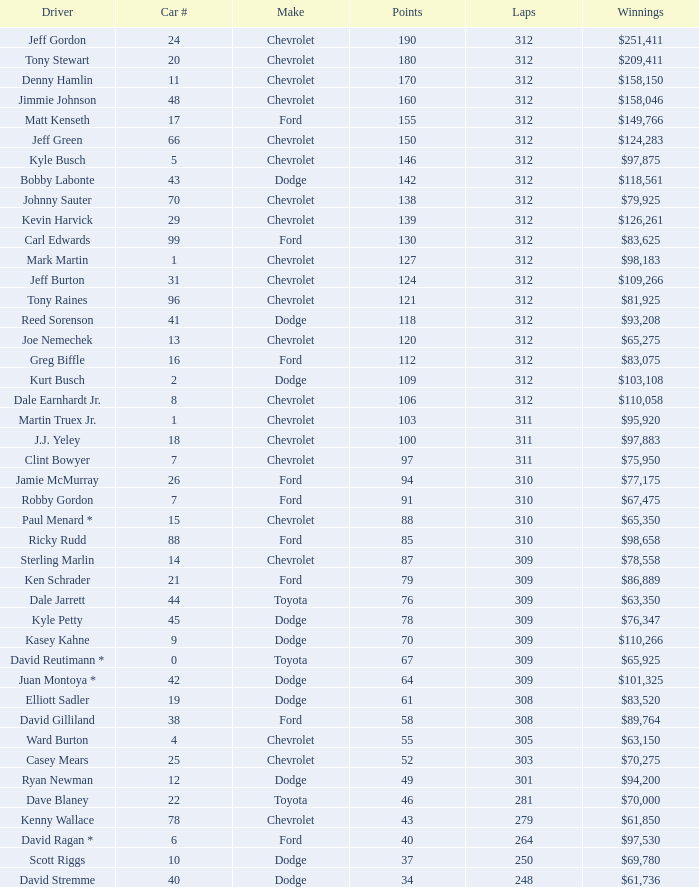What is the total number of laps for a car with a number greater than 1, belonging to ford, and having 155 points? 312.0. Help me parse the entirety of this table. {'header': ['Driver', 'Car #', 'Make', 'Points', 'Laps', 'Winnings'], 'rows': [['Jeff Gordon', '24', 'Chevrolet', '190', '312', '$251,411'], ['Tony Stewart', '20', 'Chevrolet', '180', '312', '$209,411'], ['Denny Hamlin', '11', 'Chevrolet', '170', '312', '$158,150'], ['Jimmie Johnson', '48', 'Chevrolet', '160', '312', '$158,046'], ['Matt Kenseth', '17', 'Ford', '155', '312', '$149,766'], ['Jeff Green', '66', 'Chevrolet', '150', '312', '$124,283'], ['Kyle Busch', '5', 'Chevrolet', '146', '312', '$97,875'], ['Bobby Labonte', '43', 'Dodge', '142', '312', '$118,561'], ['Johnny Sauter', '70', 'Chevrolet', '138', '312', '$79,925'], ['Kevin Harvick', '29', 'Chevrolet', '139', '312', '$126,261'], ['Carl Edwards', '99', 'Ford', '130', '312', '$83,625'], ['Mark Martin', '1', 'Chevrolet', '127', '312', '$98,183'], ['Jeff Burton', '31', 'Chevrolet', '124', '312', '$109,266'], ['Tony Raines', '96', 'Chevrolet', '121', '312', '$81,925'], ['Reed Sorenson', '41', 'Dodge', '118', '312', '$93,208'], ['Joe Nemechek', '13', 'Chevrolet', '120', '312', '$65,275'], ['Greg Biffle', '16', 'Ford', '112', '312', '$83,075'], ['Kurt Busch', '2', 'Dodge', '109', '312', '$103,108'], ['Dale Earnhardt Jr.', '8', 'Chevrolet', '106', '312', '$110,058'], ['Martin Truex Jr.', '1', 'Chevrolet', '103', '311', '$95,920'], ['J.J. Yeley', '18', 'Chevrolet', '100', '311', '$97,883'], ['Clint Bowyer', '7', 'Chevrolet', '97', '311', '$75,950'], ['Jamie McMurray', '26', 'Ford', '94', '310', '$77,175'], ['Robby Gordon', '7', 'Ford', '91', '310', '$67,475'], ['Paul Menard *', '15', 'Chevrolet', '88', '310', '$65,350'], ['Ricky Rudd', '88', 'Ford', '85', '310', '$98,658'], ['Sterling Marlin', '14', 'Chevrolet', '87', '309', '$78,558'], ['Ken Schrader', '21', 'Ford', '79', '309', '$86,889'], ['Dale Jarrett', '44', 'Toyota', '76', '309', '$63,350'], ['Kyle Petty', '45', 'Dodge', '78', '309', '$76,347'], ['Kasey Kahne', '9', 'Dodge', '70', '309', '$110,266'], ['David Reutimann *', '0', 'Toyota', '67', '309', '$65,925'], ['Juan Montoya *', '42', 'Dodge', '64', '309', '$101,325'], ['Elliott Sadler', '19', 'Dodge', '61', '308', '$83,520'], ['David Gilliland', '38', 'Ford', '58', '308', '$89,764'], ['Ward Burton', '4', 'Chevrolet', '55', '305', '$63,150'], ['Casey Mears', '25', 'Chevrolet', '52', '303', '$70,275'], ['Ryan Newman', '12', 'Dodge', '49', '301', '$94,200'], ['Dave Blaney', '22', 'Toyota', '46', '281', '$70,000'], ['Kenny Wallace', '78', 'Chevrolet', '43', '279', '$61,850'], ['David Ragan *', '6', 'Ford', '40', '264', '$97,530'], ['Scott Riggs', '10', 'Dodge', '37', '250', '$69,780'], ['David Stremme', '40', 'Dodge', '34', '248', '$61,736']]} 